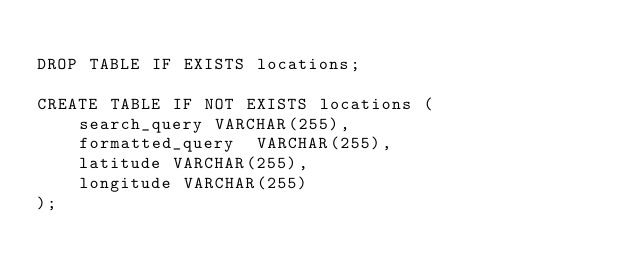<code> <loc_0><loc_0><loc_500><loc_500><_SQL_>
DROP TABLE IF EXISTS locations;

CREATE TABLE IF NOT EXISTS locations (
    search_query VARCHAR(255),
    formatted_query  VARCHAR(255),
    latitude VARCHAR(255),
    longitude VARCHAR(255)
);
</code> 